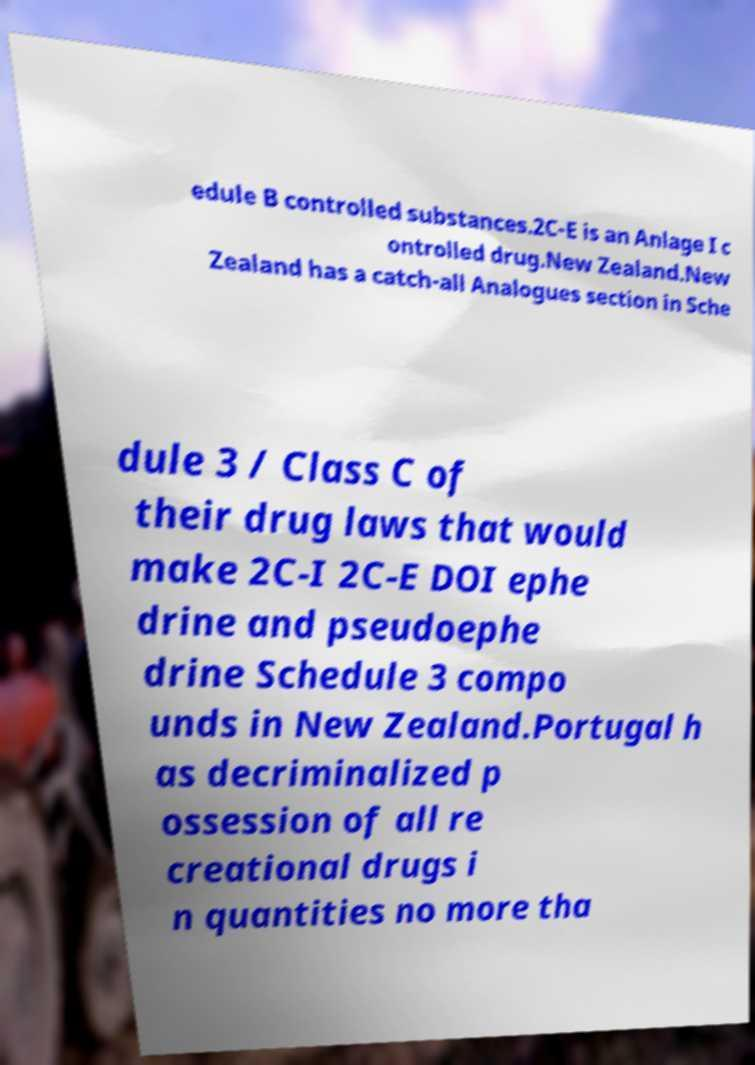There's text embedded in this image that I need extracted. Can you transcribe it verbatim? edule B controlled substances.2C-E is an Anlage I c ontrolled drug.New Zealand.New Zealand has a catch-all Analogues section in Sche dule 3 / Class C of their drug laws that would make 2C-I 2C-E DOI ephe drine and pseudoephe drine Schedule 3 compo unds in New Zealand.Portugal h as decriminalized p ossession of all re creational drugs i n quantities no more tha 